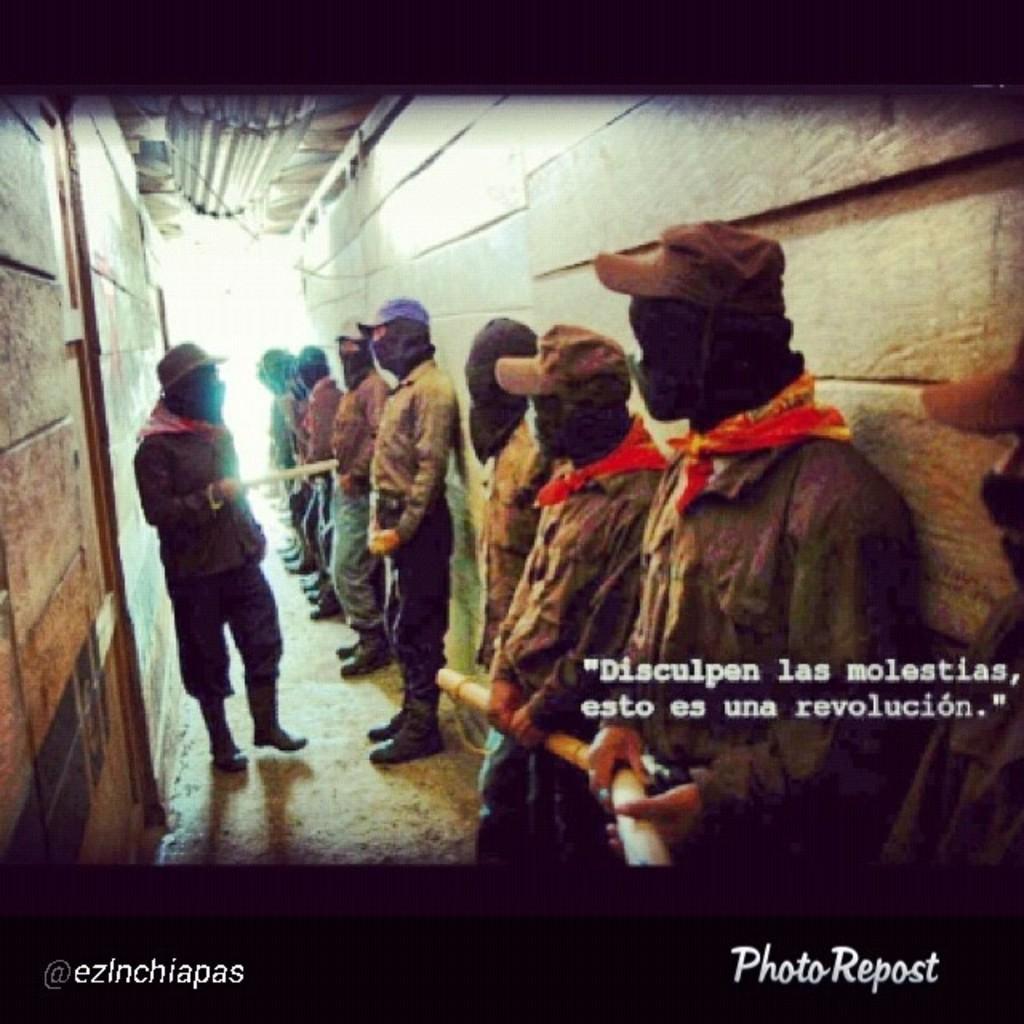Please provide a concise description of this image. This image is an edited image. There are two borders. In this image there is a text. In the middle of the image a few men are standing on the floor. A few are holding sticks in their hands. On the left and right sides of the image there are two walls. At the top of the image there is a roof. At the bottom of the image there is a floor. 